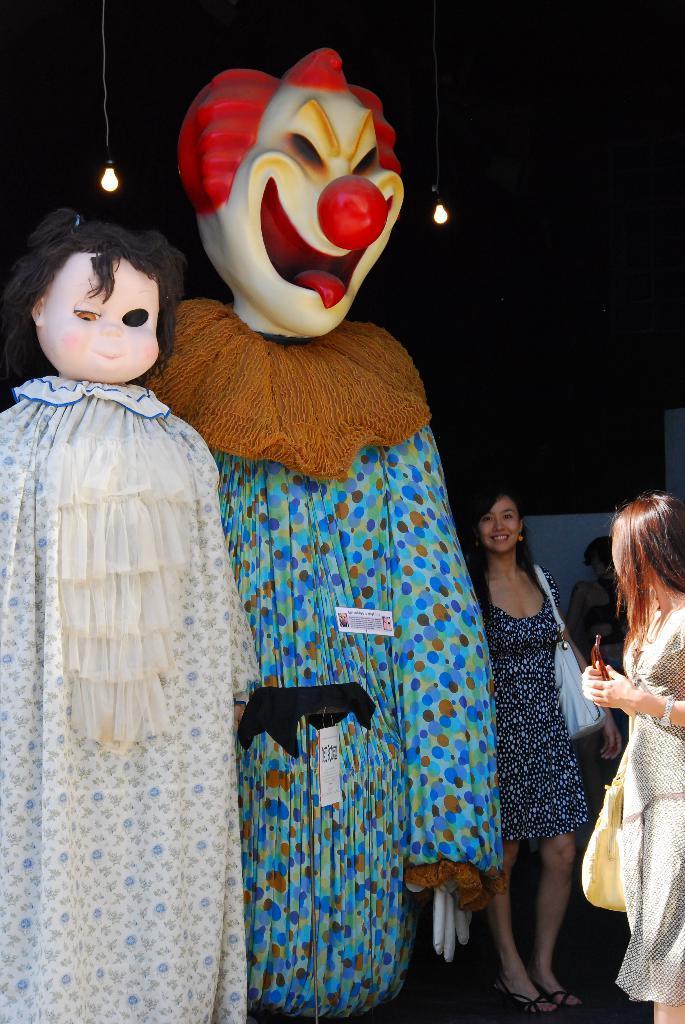In one or two sentences, can you explain what this image depicts? In this image there are two cartoon depictions. Beside them there are a few people standing. On top of the image there are lamps hanging. 